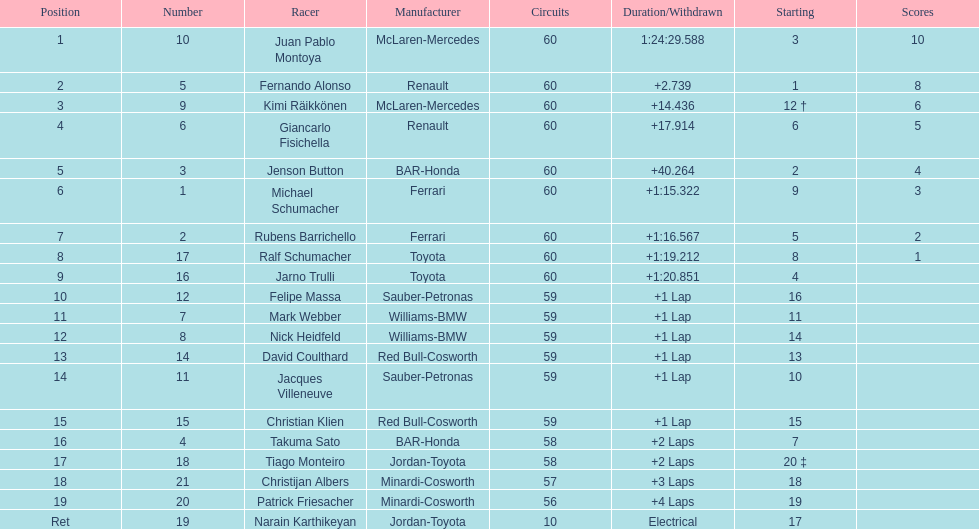Which driver has his grid at 2? Jenson Button. Can you give me this table as a dict? {'header': ['Position', 'Number', 'Racer', 'Manufacturer', 'Circuits', 'Duration/Withdrawn', 'Starting', 'Scores'], 'rows': [['1', '10', 'Juan Pablo Montoya', 'McLaren-Mercedes', '60', '1:24:29.588', '3', '10'], ['2', '5', 'Fernando Alonso', 'Renault', '60', '+2.739', '1', '8'], ['3', '9', 'Kimi Räikkönen', 'McLaren-Mercedes', '60', '+14.436', '12 †', '6'], ['4', '6', 'Giancarlo Fisichella', 'Renault', '60', '+17.914', '6', '5'], ['5', '3', 'Jenson Button', 'BAR-Honda', '60', '+40.264', '2', '4'], ['6', '1', 'Michael Schumacher', 'Ferrari', '60', '+1:15.322', '9', '3'], ['7', '2', 'Rubens Barrichello', 'Ferrari', '60', '+1:16.567', '5', '2'], ['8', '17', 'Ralf Schumacher', 'Toyota', '60', '+1:19.212', '8', '1'], ['9', '16', 'Jarno Trulli', 'Toyota', '60', '+1:20.851', '4', ''], ['10', '12', 'Felipe Massa', 'Sauber-Petronas', '59', '+1 Lap', '16', ''], ['11', '7', 'Mark Webber', 'Williams-BMW', '59', '+1 Lap', '11', ''], ['12', '8', 'Nick Heidfeld', 'Williams-BMW', '59', '+1 Lap', '14', ''], ['13', '14', 'David Coulthard', 'Red Bull-Cosworth', '59', '+1 Lap', '13', ''], ['14', '11', 'Jacques Villeneuve', 'Sauber-Petronas', '59', '+1 Lap', '10', ''], ['15', '15', 'Christian Klien', 'Red Bull-Cosworth', '59', '+1 Lap', '15', ''], ['16', '4', 'Takuma Sato', 'BAR-Honda', '58', '+2 Laps', '7', ''], ['17', '18', 'Tiago Monteiro', 'Jordan-Toyota', '58', '+2 Laps', '20 ‡', ''], ['18', '21', 'Christijan Albers', 'Minardi-Cosworth', '57', '+3 Laps', '18', ''], ['19', '20', 'Patrick Friesacher', 'Minardi-Cosworth', '56', '+4 Laps', '19', ''], ['Ret', '19', 'Narain Karthikeyan', 'Jordan-Toyota', '10', 'Electrical', '17', '']]} 